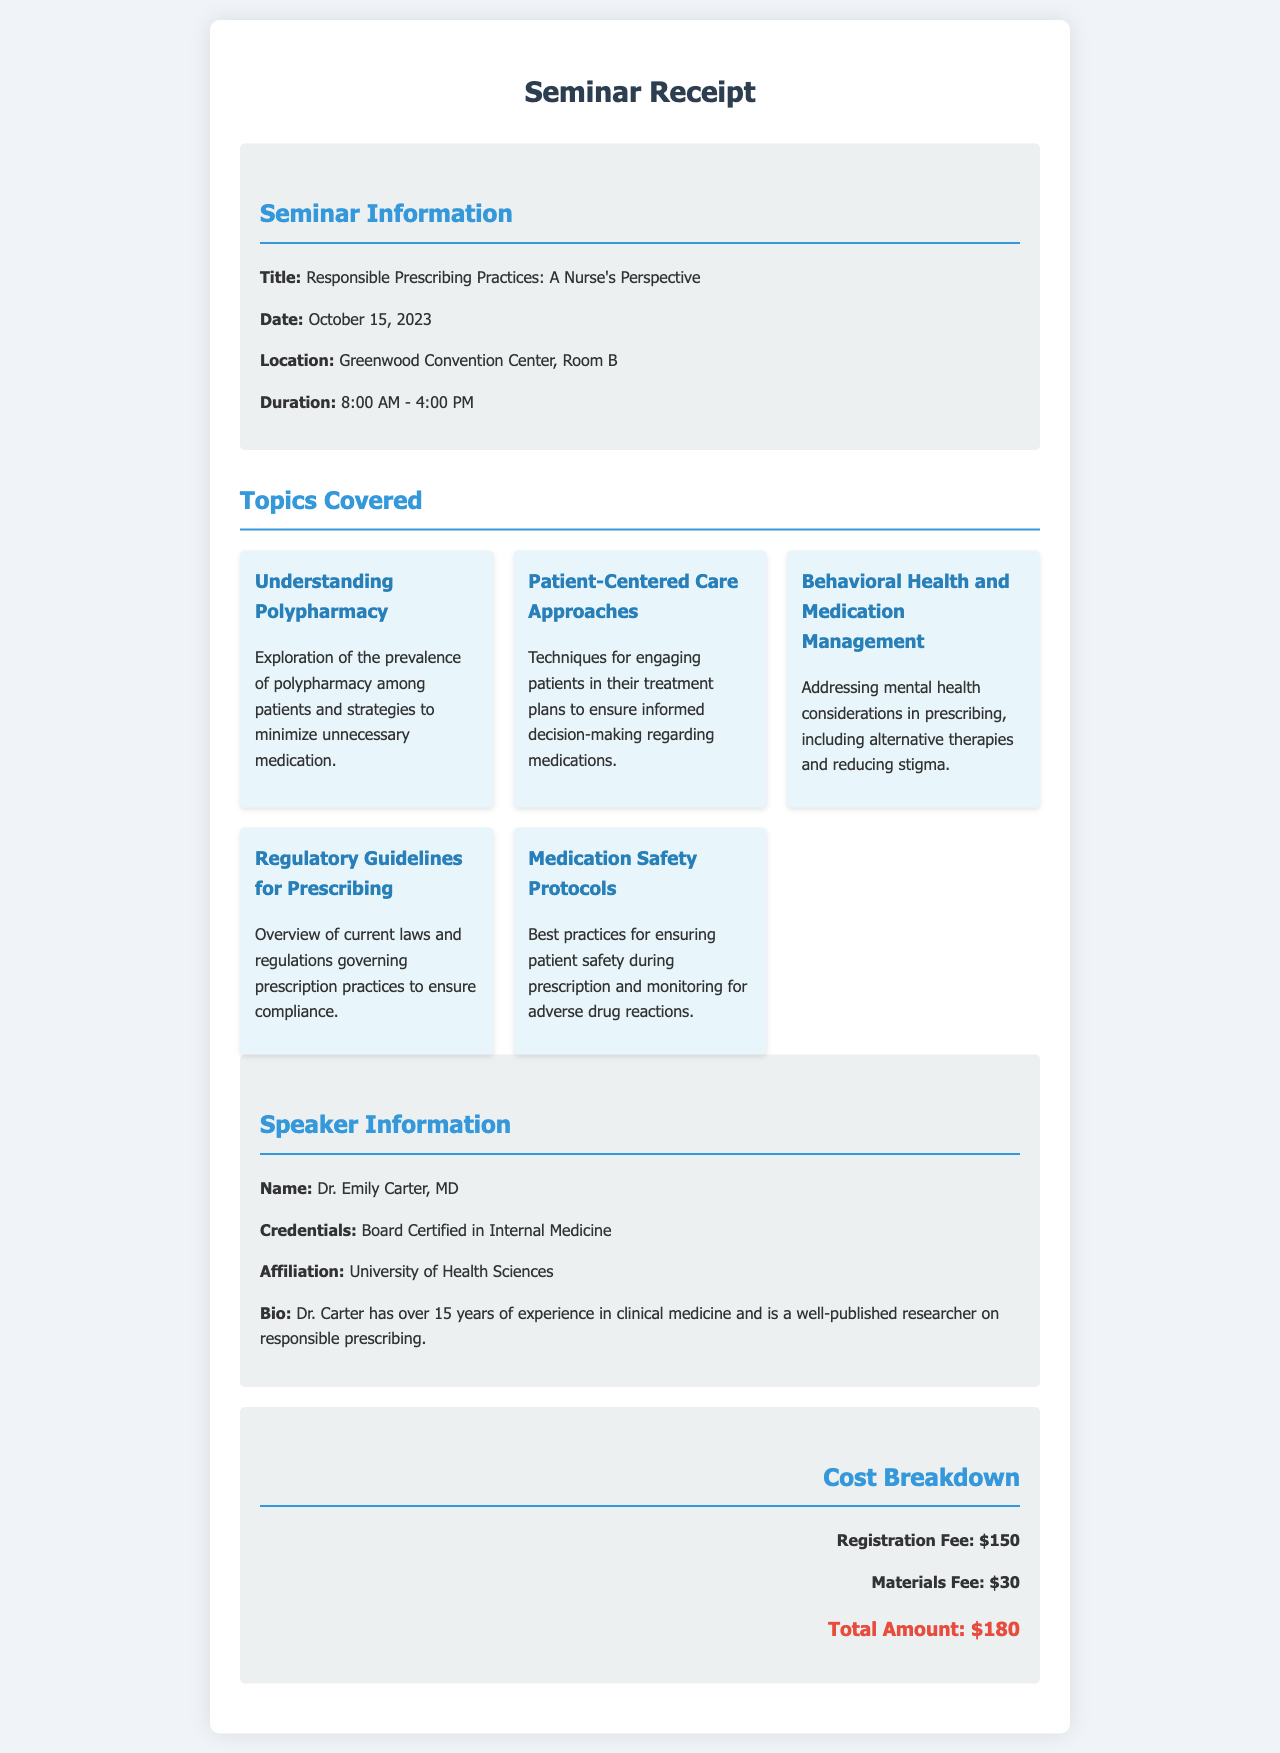what is the title of the seminar? The title is stated in the seminar information section of the document.
Answer: Responsible Prescribing Practices: A Nurse's Perspective what is the registration fee? The registration fee is listed in the cost breakdown section of the document.
Answer: $150 who is the speaker of the seminar? The speaker's name can be found in the speaker information section.
Answer: Dr. Emily Carter, MD what is the duration of the seminar? The duration is mentioned in the seminar details section, indicating the start and end times.
Answer: 8:00 AM - 4:00 PM how many topics are covered in the seminar? The number of topics can be counted from the topics covered section.
Answer: 5 what is one of the topics covered in the seminar? The specific topics are listed in the topics covered section.
Answer: Understanding Polypharmacy what is the total amount due for the seminar? The total amount can be found in the cost details section.
Answer: $180 which institution is the speaker affiliated with? The affiliation is detailed in the speaker information section of the document.
Answer: University of Health Sciences when was the seminar held? The date is specified in the seminar information section of the document.
Answer: October 15, 2023 